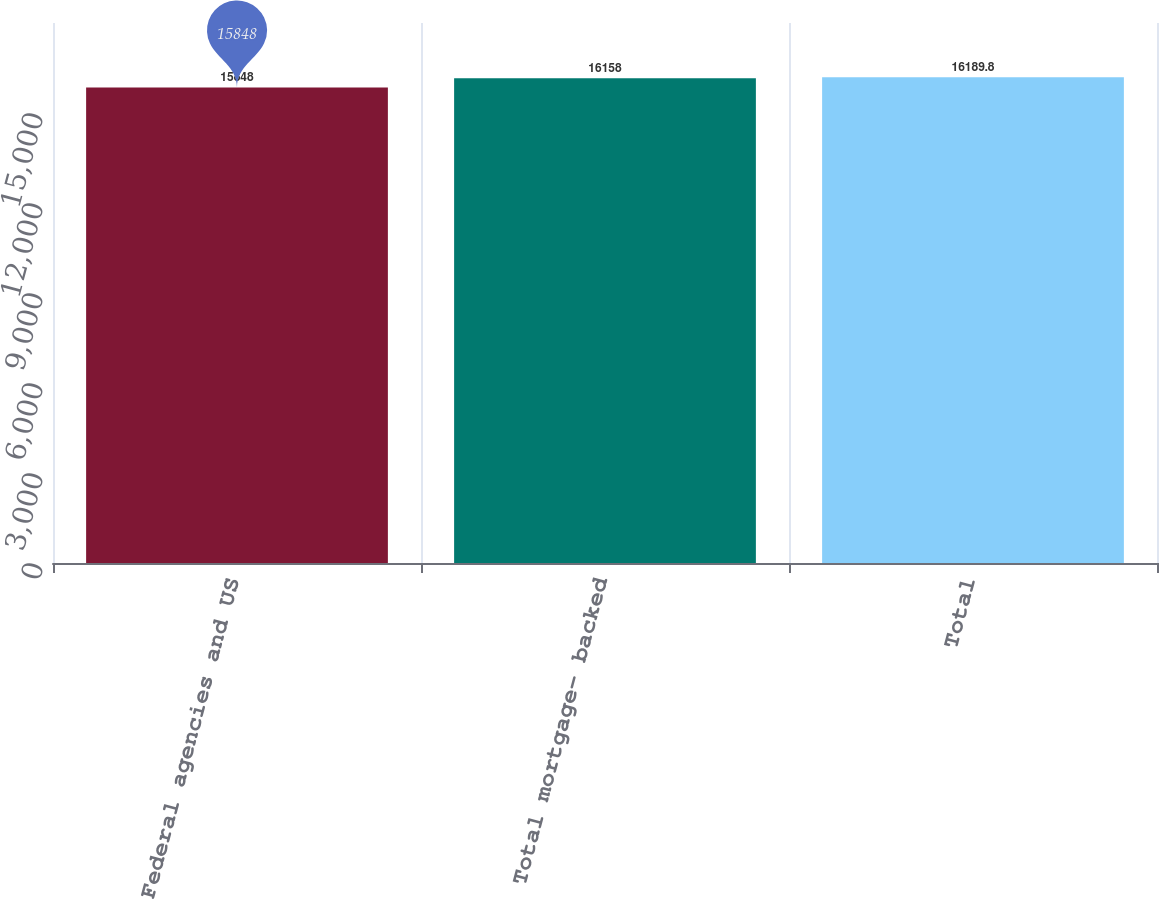<chart> <loc_0><loc_0><loc_500><loc_500><bar_chart><fcel>Federal agencies and US<fcel>Total mortgage- backed<fcel>Total<nl><fcel>15848<fcel>16158<fcel>16189.8<nl></chart> 